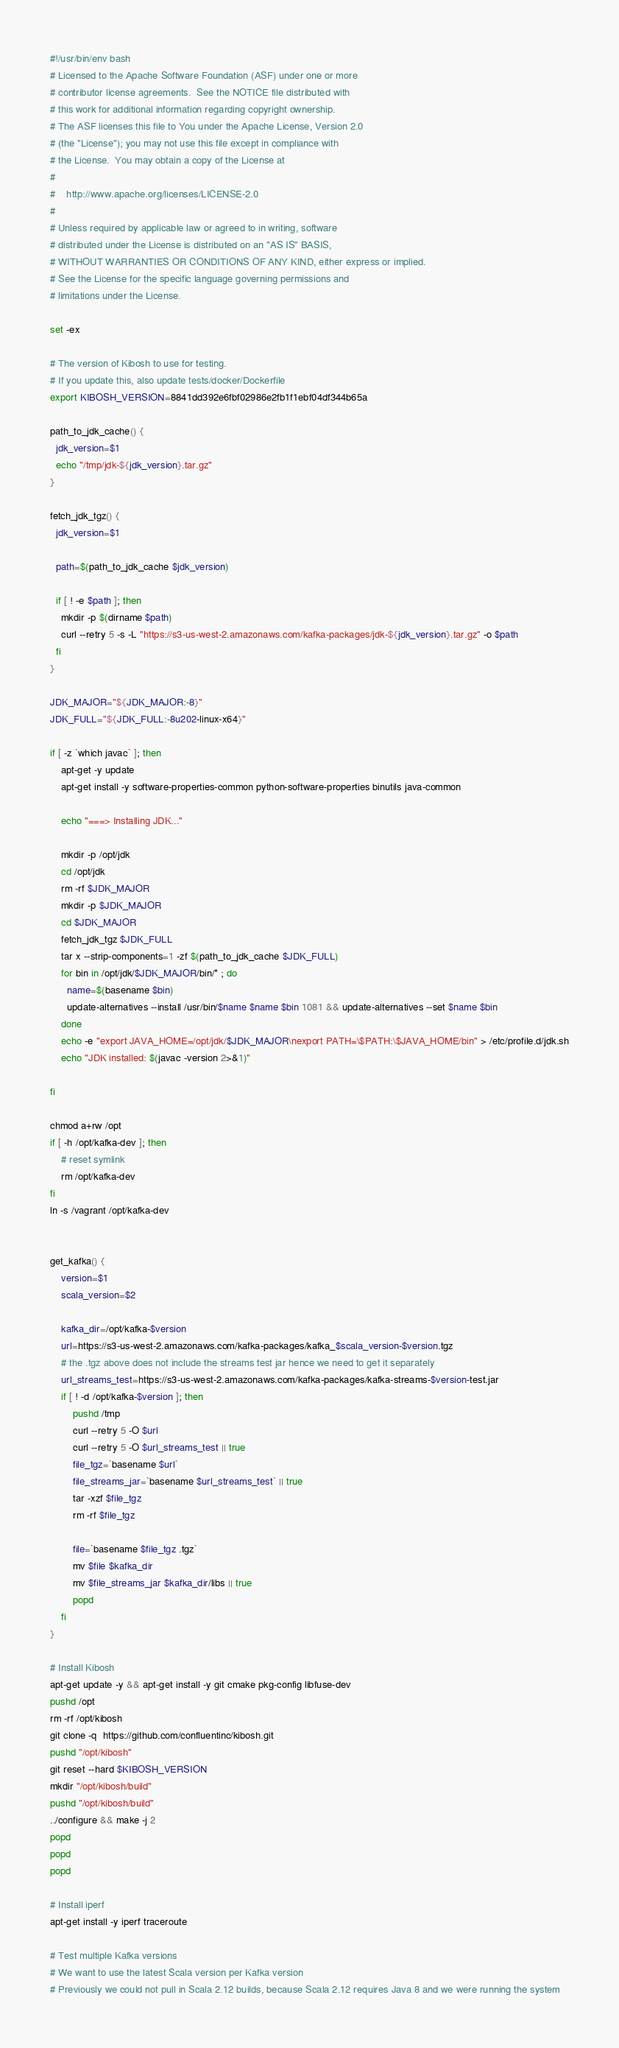Convert code to text. <code><loc_0><loc_0><loc_500><loc_500><_Bash_>#!/usr/bin/env bash
# Licensed to the Apache Software Foundation (ASF) under one or more
# contributor license agreements.  See the NOTICE file distributed with
# this work for additional information regarding copyright ownership.
# The ASF licenses this file to You under the Apache License, Version 2.0
# (the "License"); you may not use this file except in compliance with
# the License.  You may obtain a copy of the License at
#
#    http://www.apache.org/licenses/LICENSE-2.0
#
# Unless required by applicable law or agreed to in writing, software
# distributed under the License is distributed on an "AS IS" BASIS,
# WITHOUT WARRANTIES OR CONDITIONS OF ANY KIND, either express or implied.
# See the License for the specific language governing permissions and
# limitations under the License.

set -ex

# The version of Kibosh to use for testing.
# If you update this, also update tests/docker/Dockerfile
export KIBOSH_VERSION=8841dd392e6fbf02986e2fb1f1ebf04df344b65a

path_to_jdk_cache() {
  jdk_version=$1
  echo "/tmp/jdk-${jdk_version}.tar.gz"
}

fetch_jdk_tgz() {
  jdk_version=$1

  path=$(path_to_jdk_cache $jdk_version)

  if [ ! -e $path ]; then
    mkdir -p $(dirname $path)
    curl --retry 5 -s -L "https://s3-us-west-2.amazonaws.com/kafka-packages/jdk-${jdk_version}.tar.gz" -o $path
  fi
}

JDK_MAJOR="${JDK_MAJOR:-8}"
JDK_FULL="${JDK_FULL:-8u202-linux-x64}"

if [ -z `which javac` ]; then
    apt-get -y update
    apt-get install -y software-properties-common python-software-properties binutils java-common

    echo "===> Installing JDK..." 

    mkdir -p /opt/jdk
    cd /opt/jdk
    rm -rf $JDK_MAJOR
    mkdir -p $JDK_MAJOR
    cd $JDK_MAJOR
    fetch_jdk_tgz $JDK_FULL
    tar x --strip-components=1 -zf $(path_to_jdk_cache $JDK_FULL)
    for bin in /opt/jdk/$JDK_MAJOR/bin/* ; do 
      name=$(basename $bin)
      update-alternatives --install /usr/bin/$name $name $bin 1081 && update-alternatives --set $name $bin
    done
    echo -e "export JAVA_HOME=/opt/jdk/$JDK_MAJOR\nexport PATH=\$PATH:\$JAVA_HOME/bin" > /etc/profile.d/jdk.sh
    echo "JDK installed: $(javac -version 2>&1)"

fi

chmod a+rw /opt
if [ -h /opt/kafka-dev ]; then
    # reset symlink
    rm /opt/kafka-dev
fi
ln -s /vagrant /opt/kafka-dev


get_kafka() {
    version=$1
    scala_version=$2

    kafka_dir=/opt/kafka-$version
    url=https://s3-us-west-2.amazonaws.com/kafka-packages/kafka_$scala_version-$version.tgz
    # the .tgz above does not include the streams test jar hence we need to get it separately
    url_streams_test=https://s3-us-west-2.amazonaws.com/kafka-packages/kafka-streams-$version-test.jar
    if [ ! -d /opt/kafka-$version ]; then
        pushd /tmp
        curl --retry 5 -O $url
        curl --retry 5 -O $url_streams_test || true
        file_tgz=`basename $url`
        file_streams_jar=`basename $url_streams_test` || true
        tar -xzf $file_tgz
        rm -rf $file_tgz

        file=`basename $file_tgz .tgz`
        mv $file $kafka_dir
        mv $file_streams_jar $kafka_dir/libs || true
        popd
    fi
}

# Install Kibosh
apt-get update -y && apt-get install -y git cmake pkg-config libfuse-dev
pushd /opt
rm -rf /opt/kibosh
git clone -q  https://github.com/confluentinc/kibosh.git
pushd "/opt/kibosh"
git reset --hard $KIBOSH_VERSION
mkdir "/opt/kibosh/build"
pushd "/opt/kibosh/build"
../configure && make -j 2
popd
popd
popd

# Install iperf
apt-get install -y iperf traceroute

# Test multiple Kafka versions
# We want to use the latest Scala version per Kafka version
# Previously we could not pull in Scala 2.12 builds, because Scala 2.12 requires Java 8 and we were running the system</code> 